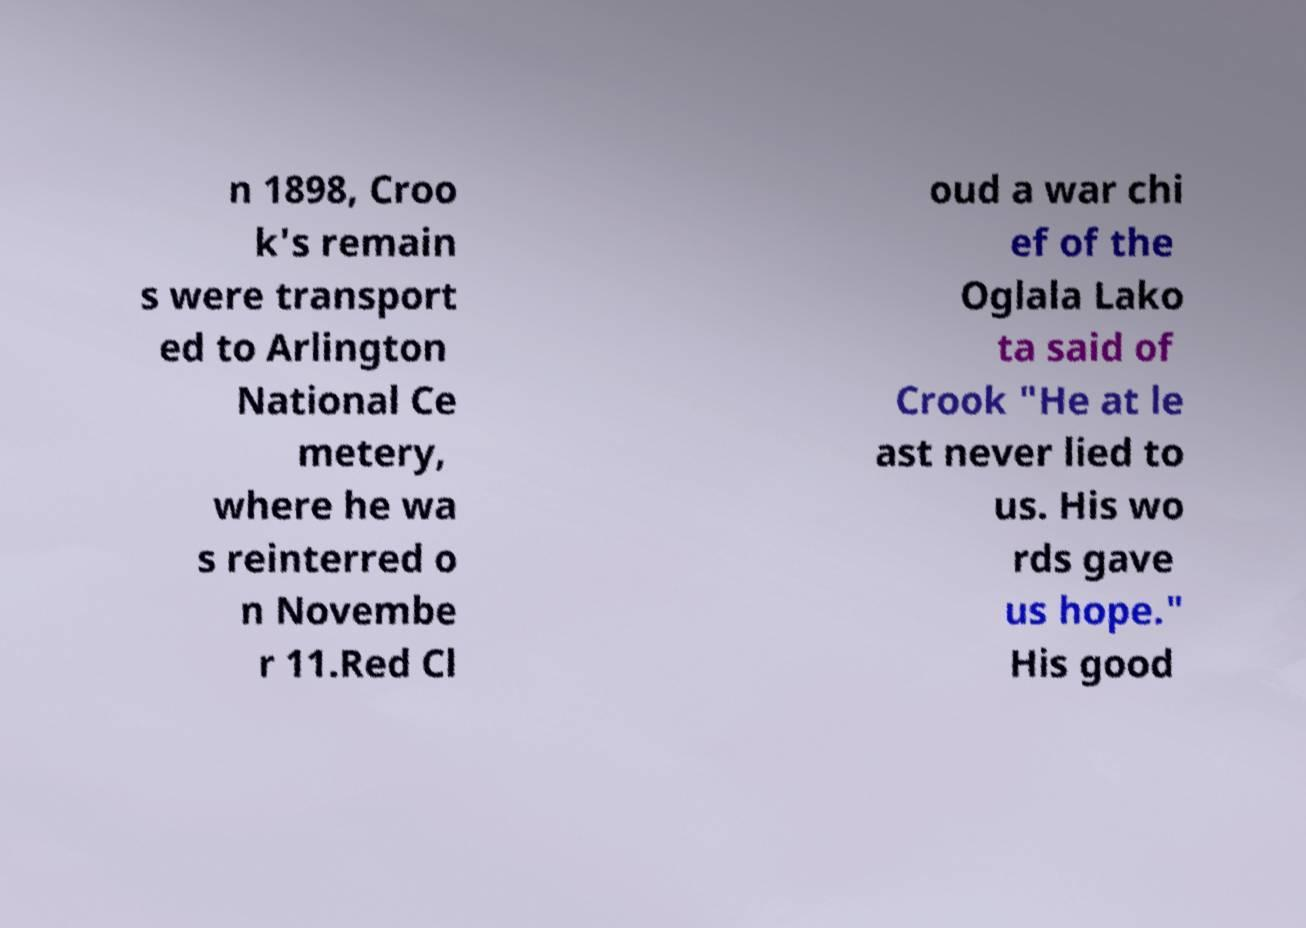Please read and relay the text visible in this image. What does it say? n 1898, Croo k's remain s were transport ed to Arlington National Ce metery, where he wa s reinterred o n Novembe r 11.Red Cl oud a war chi ef of the Oglala Lako ta said of Crook "He at le ast never lied to us. His wo rds gave us hope." His good 